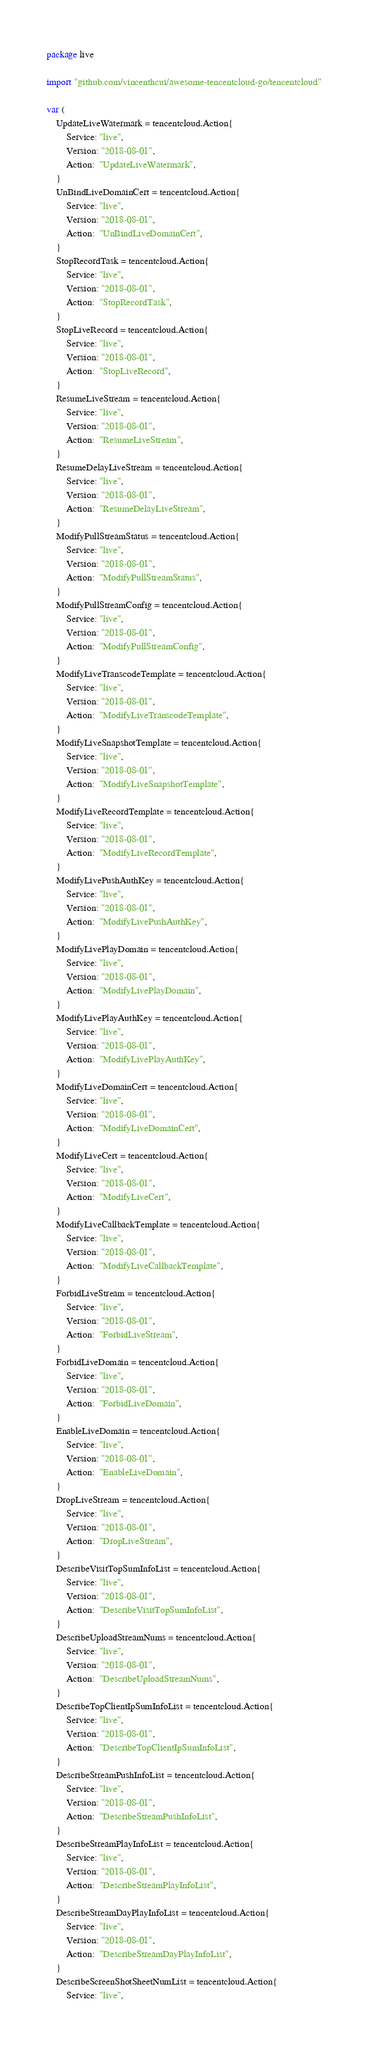<code> <loc_0><loc_0><loc_500><loc_500><_Go_>package live

import "github.com/vincenthcui/awesome-tencentcloud-go/tencentcloud"

var (
	UpdateLiveWatermark = tencentcloud.Action{
		Service: "live",
		Version: "2018-08-01",
		Action:  "UpdateLiveWatermark",
	}
	UnBindLiveDomainCert = tencentcloud.Action{
		Service: "live",
		Version: "2018-08-01",
		Action:  "UnBindLiveDomainCert",
	}
	StopRecordTask = tencentcloud.Action{
		Service: "live",
		Version: "2018-08-01",
		Action:  "StopRecordTask",
	}
	StopLiveRecord = tencentcloud.Action{
		Service: "live",
		Version: "2018-08-01",
		Action:  "StopLiveRecord",
	}
	ResumeLiveStream = tencentcloud.Action{
		Service: "live",
		Version: "2018-08-01",
		Action:  "ResumeLiveStream",
	}
	ResumeDelayLiveStream = tencentcloud.Action{
		Service: "live",
		Version: "2018-08-01",
		Action:  "ResumeDelayLiveStream",
	}
	ModifyPullStreamStatus = tencentcloud.Action{
		Service: "live",
		Version: "2018-08-01",
		Action:  "ModifyPullStreamStatus",
	}
	ModifyPullStreamConfig = tencentcloud.Action{
		Service: "live",
		Version: "2018-08-01",
		Action:  "ModifyPullStreamConfig",
	}
	ModifyLiveTranscodeTemplate = tencentcloud.Action{
		Service: "live",
		Version: "2018-08-01",
		Action:  "ModifyLiveTranscodeTemplate",
	}
	ModifyLiveSnapshotTemplate = tencentcloud.Action{
		Service: "live",
		Version: "2018-08-01",
		Action:  "ModifyLiveSnapshotTemplate",
	}
	ModifyLiveRecordTemplate = tencentcloud.Action{
		Service: "live",
		Version: "2018-08-01",
		Action:  "ModifyLiveRecordTemplate",
	}
	ModifyLivePushAuthKey = tencentcloud.Action{
		Service: "live",
		Version: "2018-08-01",
		Action:  "ModifyLivePushAuthKey",
	}
	ModifyLivePlayDomain = tencentcloud.Action{
		Service: "live",
		Version: "2018-08-01",
		Action:  "ModifyLivePlayDomain",
	}
	ModifyLivePlayAuthKey = tencentcloud.Action{
		Service: "live",
		Version: "2018-08-01",
		Action:  "ModifyLivePlayAuthKey",
	}
	ModifyLiveDomainCert = tencentcloud.Action{
		Service: "live",
		Version: "2018-08-01",
		Action:  "ModifyLiveDomainCert",
	}
	ModifyLiveCert = tencentcloud.Action{
		Service: "live",
		Version: "2018-08-01",
		Action:  "ModifyLiveCert",
	}
	ModifyLiveCallbackTemplate = tencentcloud.Action{
		Service: "live",
		Version: "2018-08-01",
		Action:  "ModifyLiveCallbackTemplate",
	}
	ForbidLiveStream = tencentcloud.Action{
		Service: "live",
		Version: "2018-08-01",
		Action:  "ForbidLiveStream",
	}
	ForbidLiveDomain = tencentcloud.Action{
		Service: "live",
		Version: "2018-08-01",
		Action:  "ForbidLiveDomain",
	}
	EnableLiveDomain = tencentcloud.Action{
		Service: "live",
		Version: "2018-08-01",
		Action:  "EnableLiveDomain",
	}
	DropLiveStream = tencentcloud.Action{
		Service: "live",
		Version: "2018-08-01",
		Action:  "DropLiveStream",
	}
	DescribeVisitTopSumInfoList = tencentcloud.Action{
		Service: "live",
		Version: "2018-08-01",
		Action:  "DescribeVisitTopSumInfoList",
	}
	DescribeUploadStreamNums = tencentcloud.Action{
		Service: "live",
		Version: "2018-08-01",
		Action:  "DescribeUploadStreamNums",
	}
	DescribeTopClientIpSumInfoList = tencentcloud.Action{
		Service: "live",
		Version: "2018-08-01",
		Action:  "DescribeTopClientIpSumInfoList",
	}
	DescribeStreamPushInfoList = tencentcloud.Action{
		Service: "live",
		Version: "2018-08-01",
		Action:  "DescribeStreamPushInfoList",
	}
	DescribeStreamPlayInfoList = tencentcloud.Action{
		Service: "live",
		Version: "2018-08-01",
		Action:  "DescribeStreamPlayInfoList",
	}
	DescribeStreamDayPlayInfoList = tencentcloud.Action{
		Service: "live",
		Version: "2018-08-01",
		Action:  "DescribeStreamDayPlayInfoList",
	}
	DescribeScreenShotSheetNumList = tencentcloud.Action{
		Service: "live",</code> 